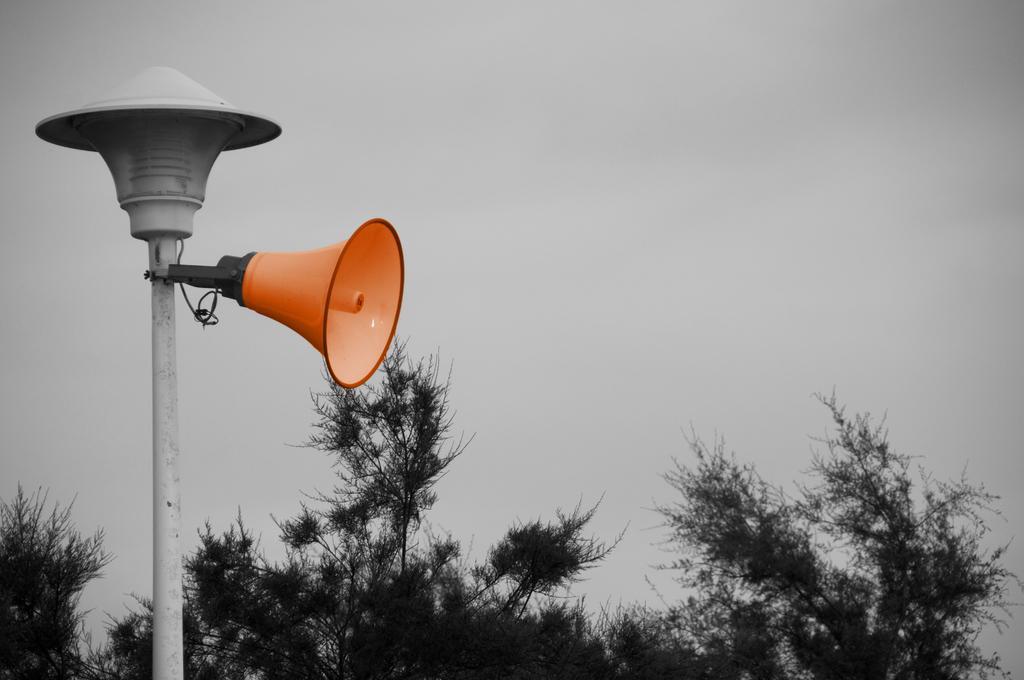Can you describe this image briefly? To the left side of the image there is a pole, to which there is a speaker. At the bottom of the image there are trees. In the background of the image there is sky. 